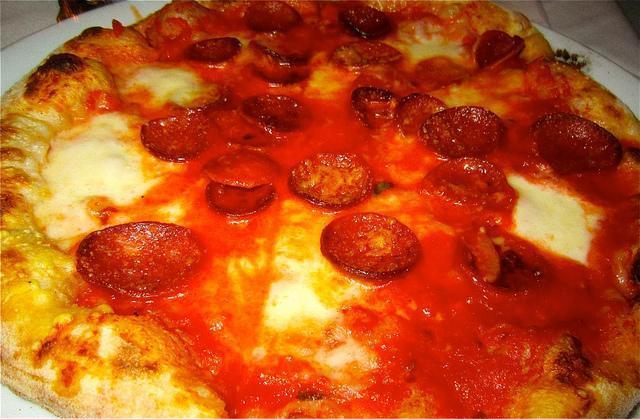How many pizzas can be seen?
Give a very brief answer. 1. 